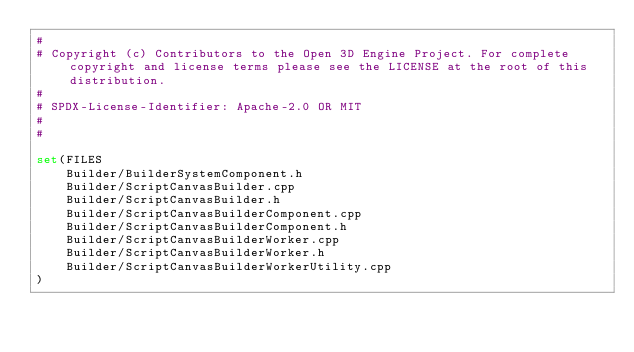Convert code to text. <code><loc_0><loc_0><loc_500><loc_500><_CMake_>#
# Copyright (c) Contributors to the Open 3D Engine Project. For complete copyright and license terms please see the LICENSE at the root of this distribution.
# 
# SPDX-License-Identifier: Apache-2.0 OR MIT
#
#

set(FILES
    Builder/BuilderSystemComponent.h
    Builder/ScriptCanvasBuilder.cpp
    Builder/ScriptCanvasBuilder.h
    Builder/ScriptCanvasBuilderComponent.cpp
    Builder/ScriptCanvasBuilderComponent.h
    Builder/ScriptCanvasBuilderWorker.cpp
    Builder/ScriptCanvasBuilderWorker.h
    Builder/ScriptCanvasBuilderWorkerUtility.cpp
)
</code> 